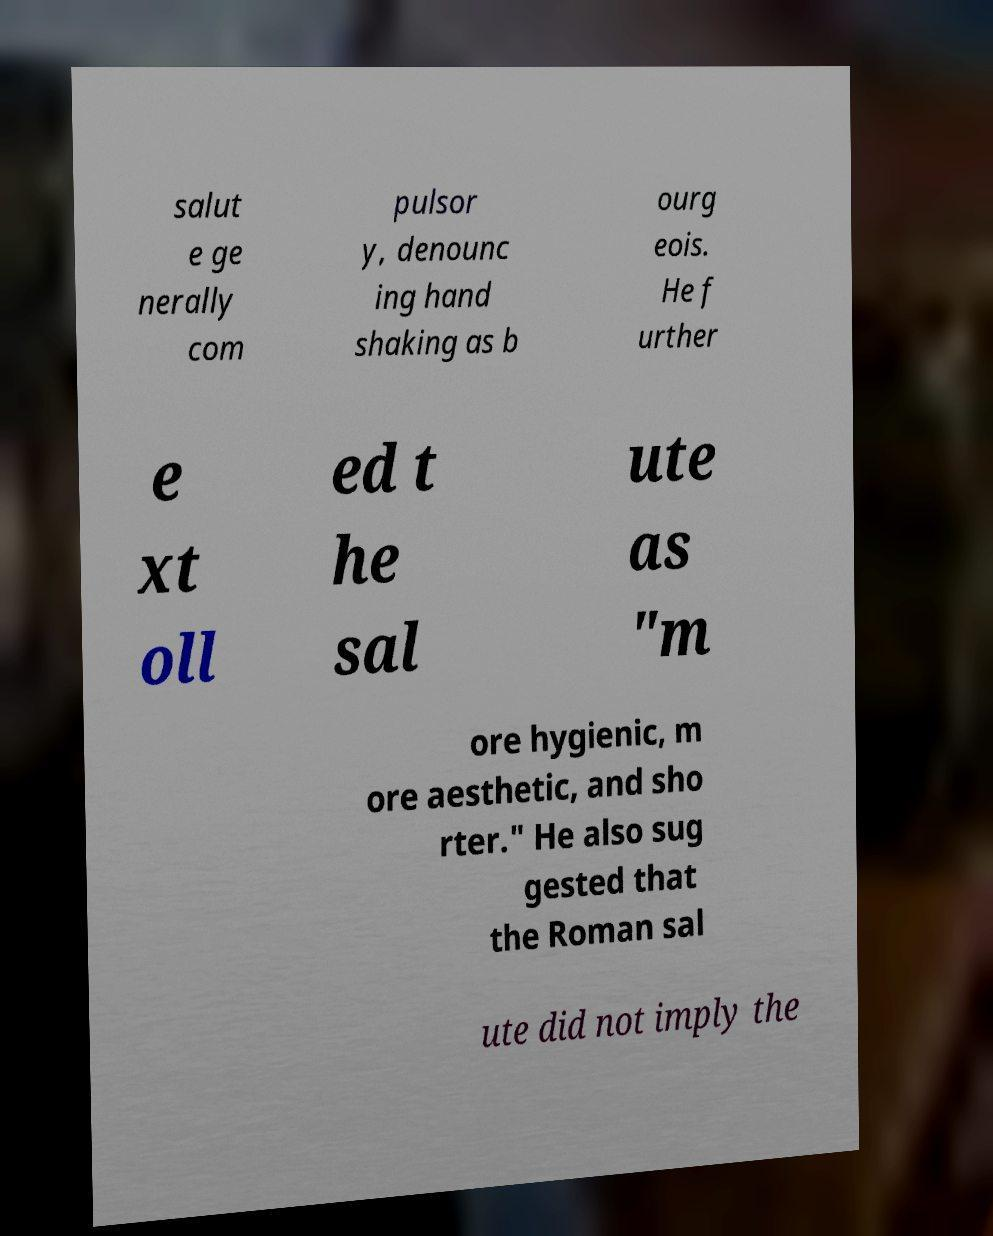I need the written content from this picture converted into text. Can you do that? salut e ge nerally com pulsor y, denounc ing hand shaking as b ourg eois. He f urther e xt oll ed t he sal ute as "m ore hygienic, m ore aesthetic, and sho rter." He also sug gested that the Roman sal ute did not imply the 